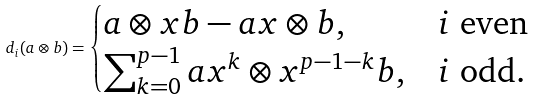Convert formula to latex. <formula><loc_0><loc_0><loc_500><loc_500>d _ { i } ( a \otimes b ) = \begin{cases} a \otimes x b - a x \otimes b , & i \text { even} \\ \sum _ { k = 0 } ^ { p - 1 } a x ^ { k } \otimes x ^ { p - 1 - k } b , & i \text { odd} . \end{cases}</formula> 